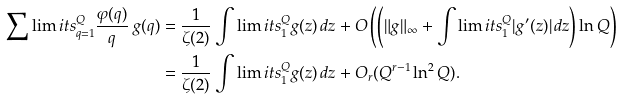Convert formula to latex. <formula><loc_0><loc_0><loc_500><loc_500>\sum \lim i t s _ { q = 1 } ^ { Q } \frac { \varphi ( q ) } { q } \, g ( q ) & = \frac { 1 } { \zeta ( 2 ) } \int \lim i t s _ { 1 } ^ { Q } g ( z ) \, d z + O \left ( \left ( \| g \| _ { \infty } + \int \lim i t s _ { 1 } ^ { Q } | g ^ { \prime } ( z ) | \, d z \right ) \ln Q \right ) \\ & = \frac { 1 } { \zeta ( 2 ) } \int \lim i t s _ { 1 } ^ { Q } g ( z ) \, d z + O _ { r } ( Q ^ { r - 1 } \ln ^ { 2 } Q ) .</formula> 